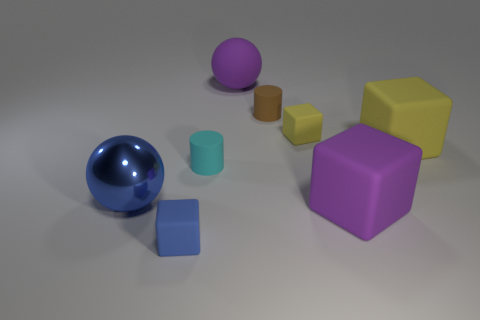Subtract all brown cubes. Subtract all red balls. How many cubes are left? 4 Add 1 purple blocks. How many objects exist? 9 Subtract all spheres. How many objects are left? 6 Add 2 large yellow matte things. How many large yellow matte things exist? 3 Subtract 0 gray spheres. How many objects are left? 8 Subtract all small cylinders. Subtract all shiny things. How many objects are left? 5 Add 4 large purple matte things. How many large purple matte things are left? 6 